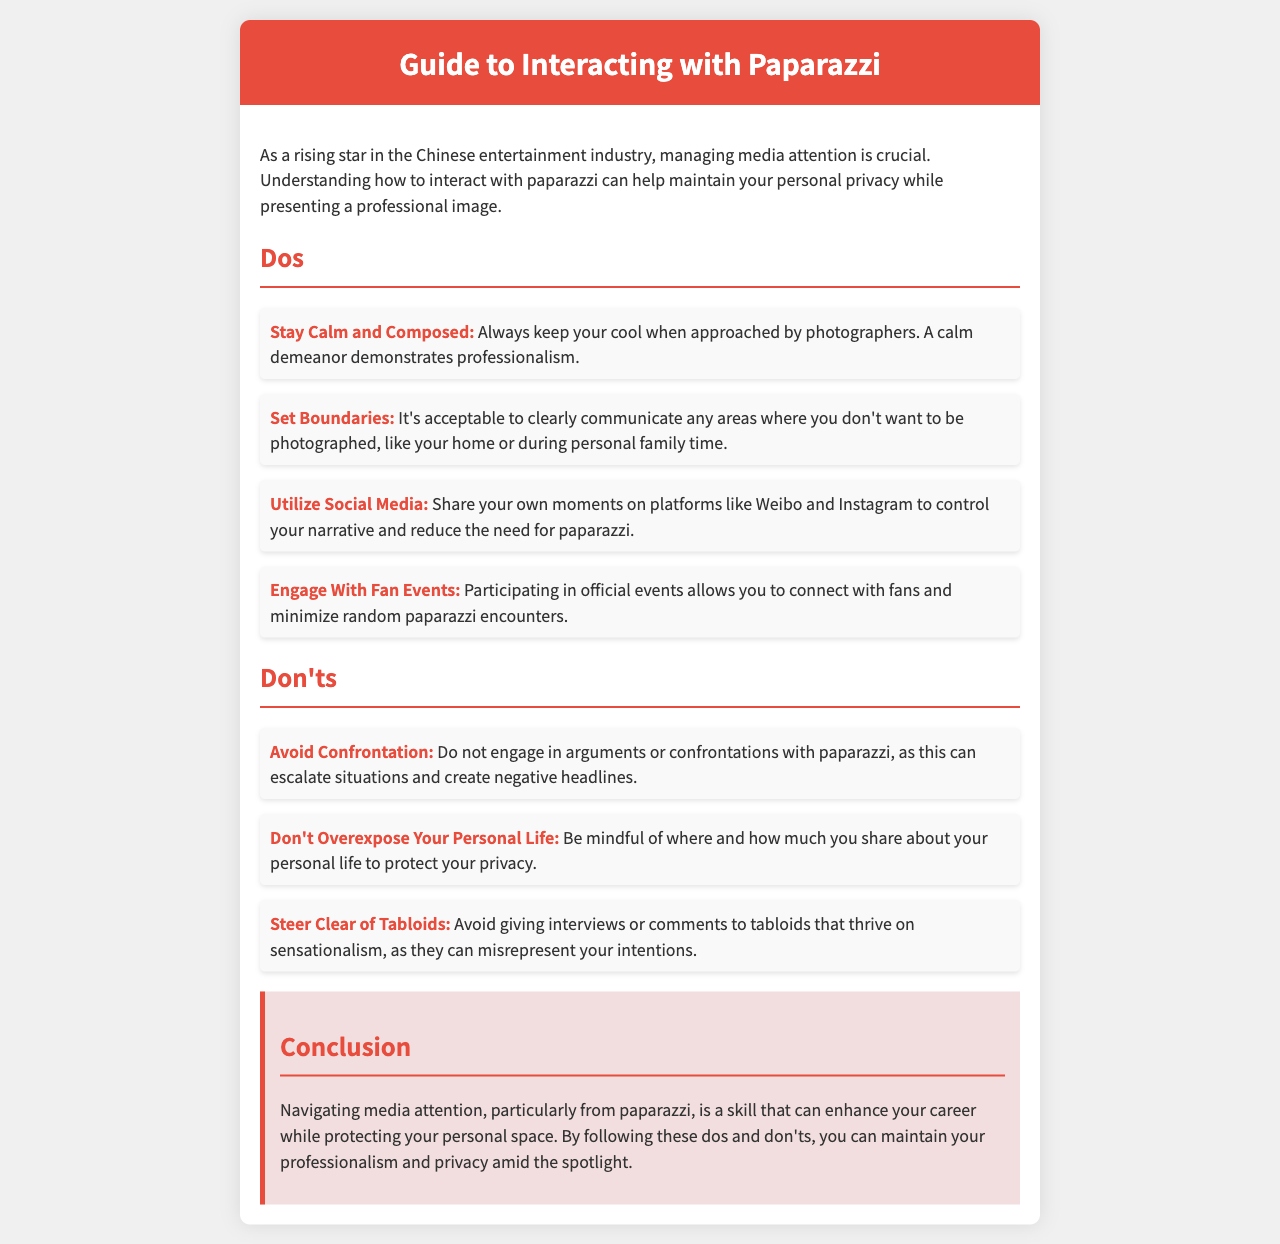What is the document about? The document provides guidance on how to interact with paparazzi for rising stars in the Chinese entertainment industry.
Answer: Interacting with paparazzi What is one thing you should do when approached by paparazzi? The document highlights the importance of staying calm and composed when approached by photographers.
Answer: Stay calm and composed What should you avoid doing in interactions with paparazzi? The document states that you should not engage in arguments or confrontations with paparazzi.
Answer: Avoid confrontation What platform can you use to share your moments? The document mentions utilizing social media platforms like Weibo and Instagram to control your narrative.
Answer: Weibo and Instagram What is an acceptable way to protect your personal space? One acceptable way mentioned in the document is to clearly communicate areas where you don't want to be photographed.
Answer: Set boundaries What type of events does the document suggest attending to connect with fans? The document suggests engaging with fan events as a way to connect with fans.
Answer: Fan events Which media source should you steer clear of? The document advises against giving interviews or comments to tabloids.
Answer: Tabloids What kind of privacy should you be mindful of? The document emphasizes the importance of not overexposing your personal life to protect your privacy.
Answer: Personal life What is the tone of the document? The tone of the document is informative and professional, aimed at guiding individuals on interacting with the media.
Answer: Informative and professional 